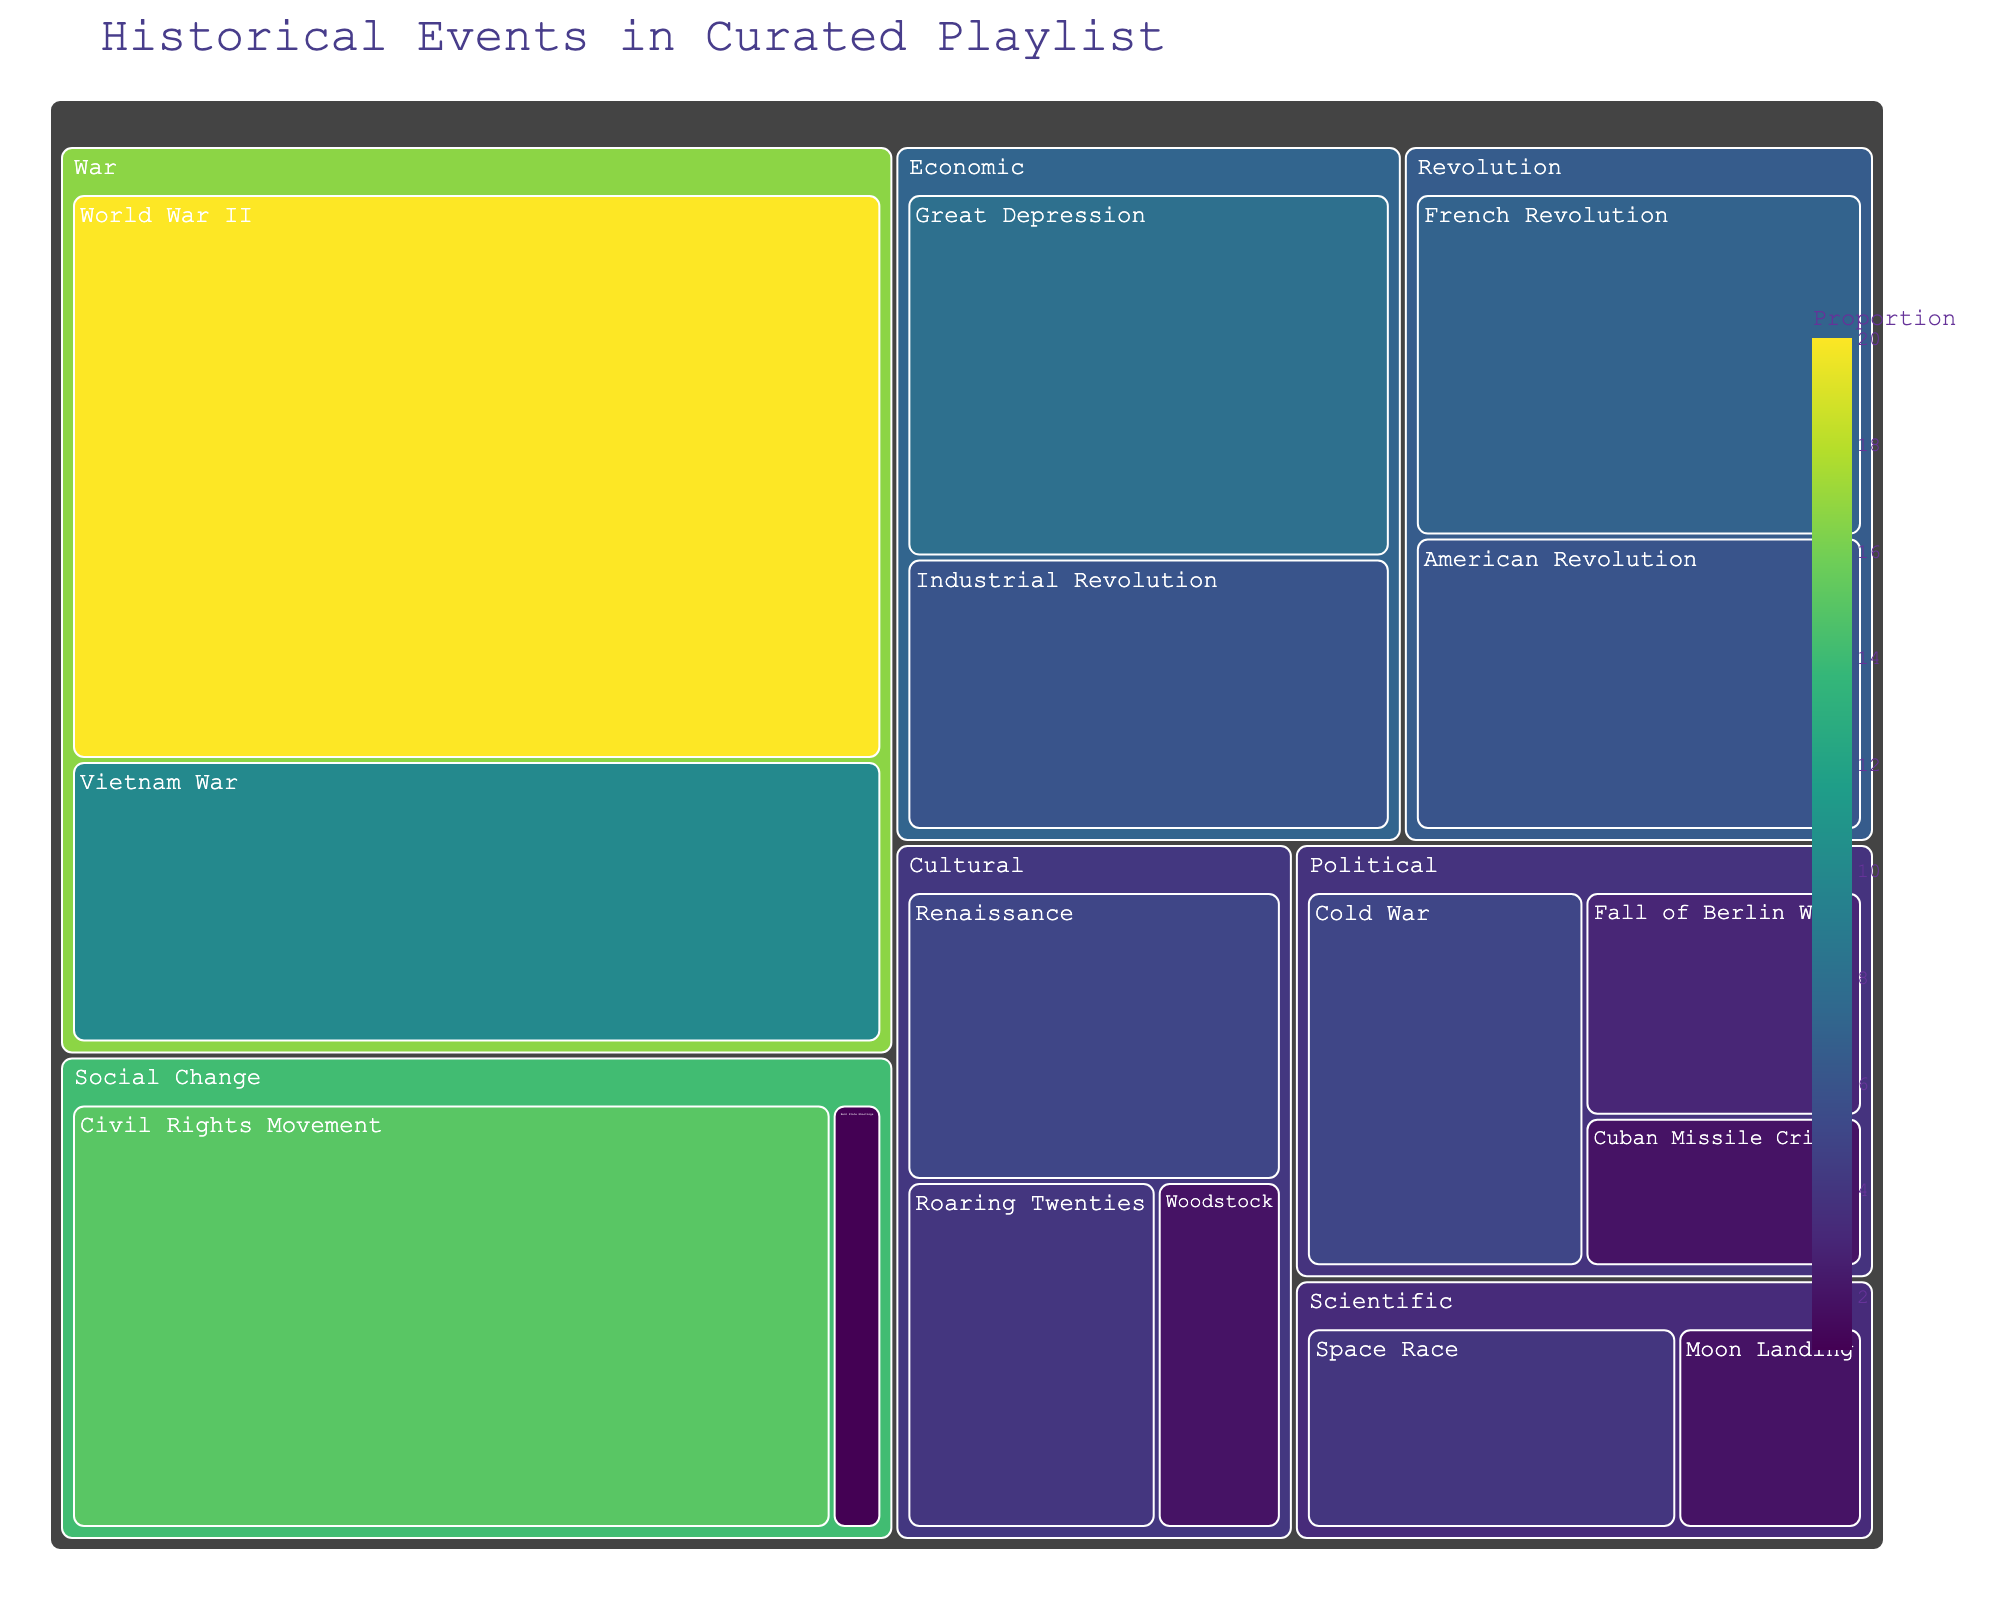What is the title of the figure? Look at the top of the figure to find the large text that summarizes what the visualization shows. The title is usually prominently displayed.
Answer: Historical Events in Curated Playlist Which category has the most significant proportion overall? Identify the category with the largest combined area in the treemap. The category with the largest blocks will have the greatest proportion.
Answer: War What proportion of the playlist is related to Social Change? Find the text within the blocks labeled as "Social Change" and sum their proportions if there are multiple blocks.
Answer: 16 Which event has the highest individual proportion? Look for the individual block with the largest area and check its label and proportion value.
Answer: World War II What is the combined proportion of songs from the 'Revolution' category? Locate the blocks under 'Revolution' and sum all their proportions. This involves adding the proportions of French Revolution and American Revolution.
Answer: 13 Which historical events are categorized under 'Cultural'? Identify all blocks labeled 'Cultural' and list the corresponding historical event names.
Answer: Renaissance, Roaring Twenties, Woodstock Between the 'Scientific' and 'Political' categories, which has a larger combined proportion, and by how much? Add up the proportions for each event under 'Scientific' and 'Political' categories and compare the totals to find the difference.
Answer: Political by 2 What is the average proportion of songs from events in the 'Economic' category? Sum the proportions of all events under 'Economic' and divide by the number of these events (Great Depression, Industrial Revolution).
Answer: 7 Which historical event within the 'Political' category has the smallest proportion? Look among the blocks within the 'Political' category to find and identify the block with the lowest proportion.
Answer: Cuban Missile Crisis Are there more songs related to 'War' or 'Social Change'? Sum the proportions of the events under both categories and compare. 'War' includes World War II and Vietnam War.
Answer: War 